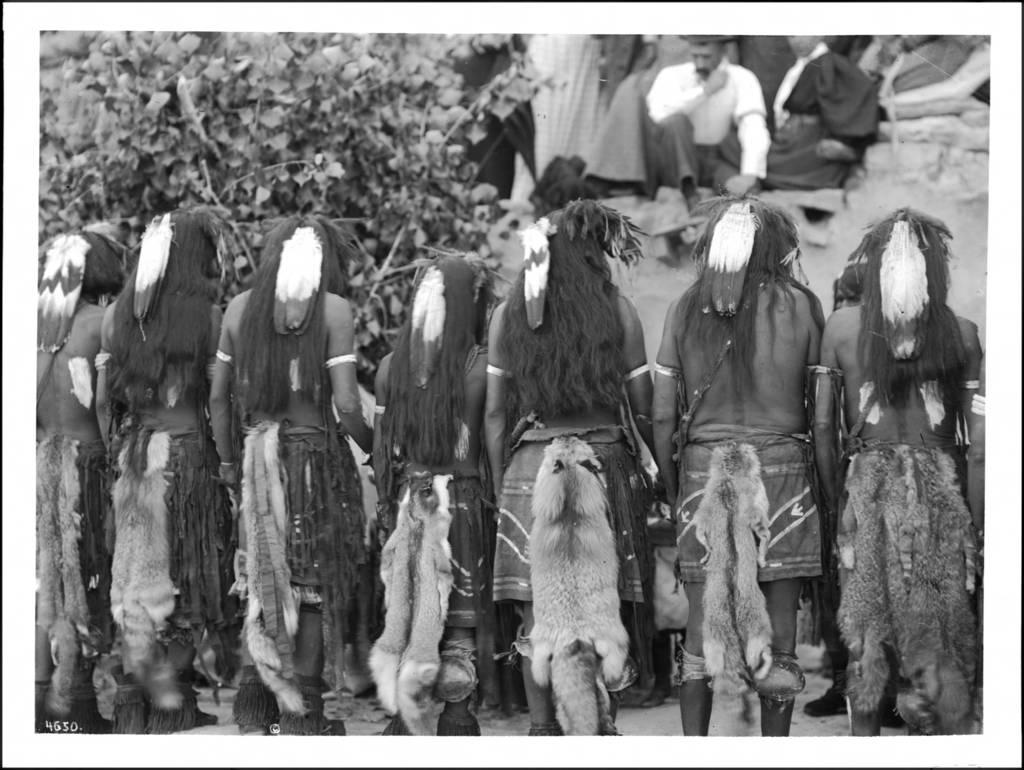How many people are in the image? There is a group of people in the image, but the exact number is not specified. What are the people in the image doing? Some people are seated, while others are standing. What can be seen in the background of the image? There is a tree visible in the image. What is the color scheme of the image? The photography is in black and white. What type of van can be seen in the image? There is no van present in the image. How old is the baby in the image? There is no baby present in the image. 